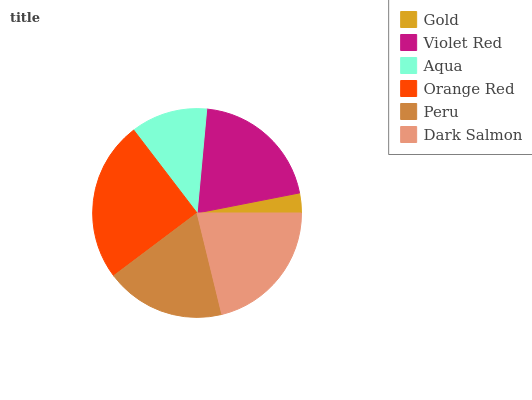Is Gold the minimum?
Answer yes or no. Yes. Is Orange Red the maximum?
Answer yes or no. Yes. Is Violet Red the minimum?
Answer yes or no. No. Is Violet Red the maximum?
Answer yes or no. No. Is Violet Red greater than Gold?
Answer yes or no. Yes. Is Gold less than Violet Red?
Answer yes or no. Yes. Is Gold greater than Violet Red?
Answer yes or no. No. Is Violet Red less than Gold?
Answer yes or no. No. Is Violet Red the high median?
Answer yes or no. Yes. Is Peru the low median?
Answer yes or no. Yes. Is Gold the high median?
Answer yes or no. No. Is Aqua the low median?
Answer yes or no. No. 